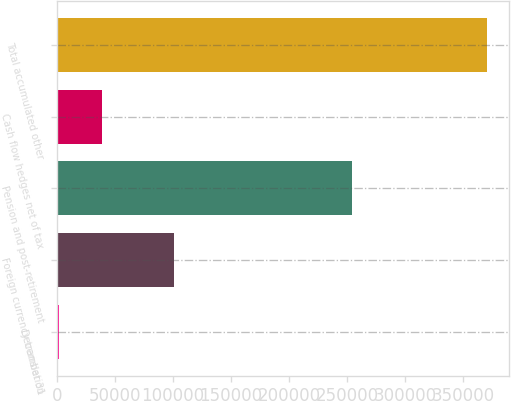<chart> <loc_0><loc_0><loc_500><loc_500><bar_chart><fcel>December 31<fcel>Foreign currency translation<fcel>Pension and post-retirement<fcel>Cash flow hedges net of tax<fcel>Total accumulated other<nl><fcel>2015<fcel>101236<fcel>254648<fcel>38916<fcel>371025<nl></chart> 